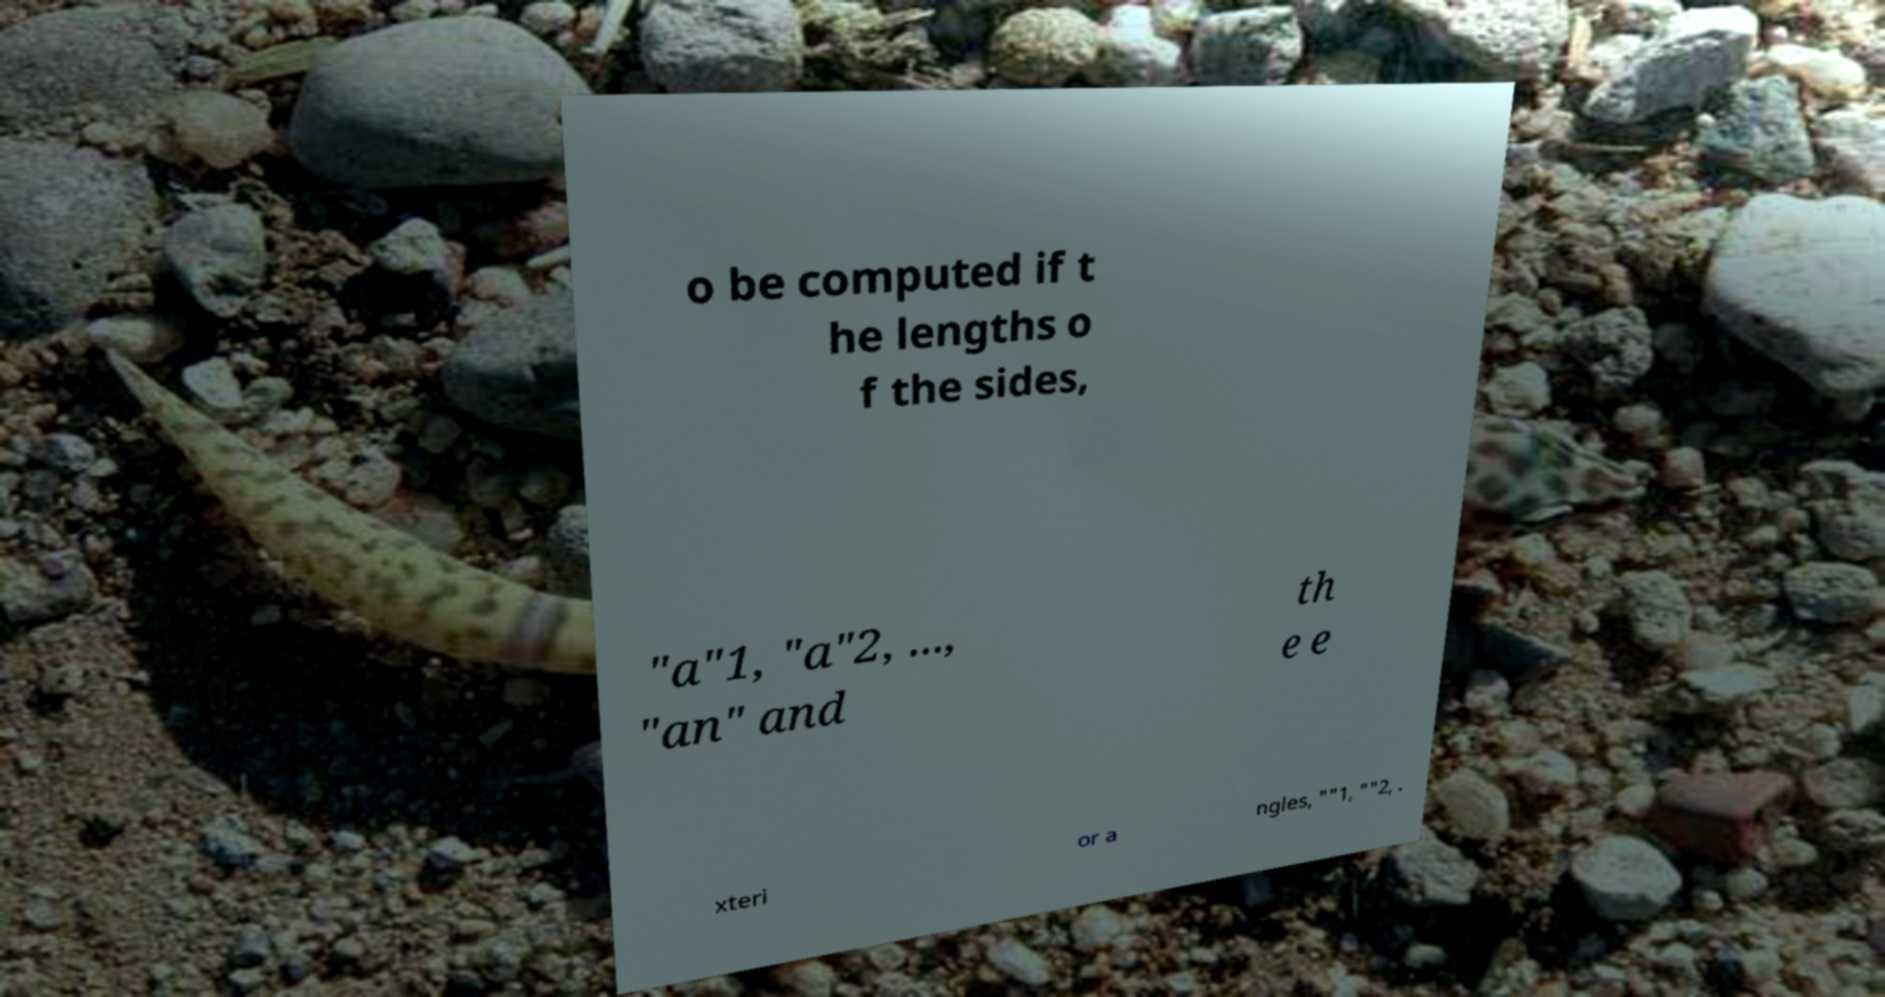Could you assist in decoding the text presented in this image and type it out clearly? o be computed if t he lengths o f the sides, "a"1, "a"2, ..., "an" and th e e xteri or a ngles, ""1, ""2, . 